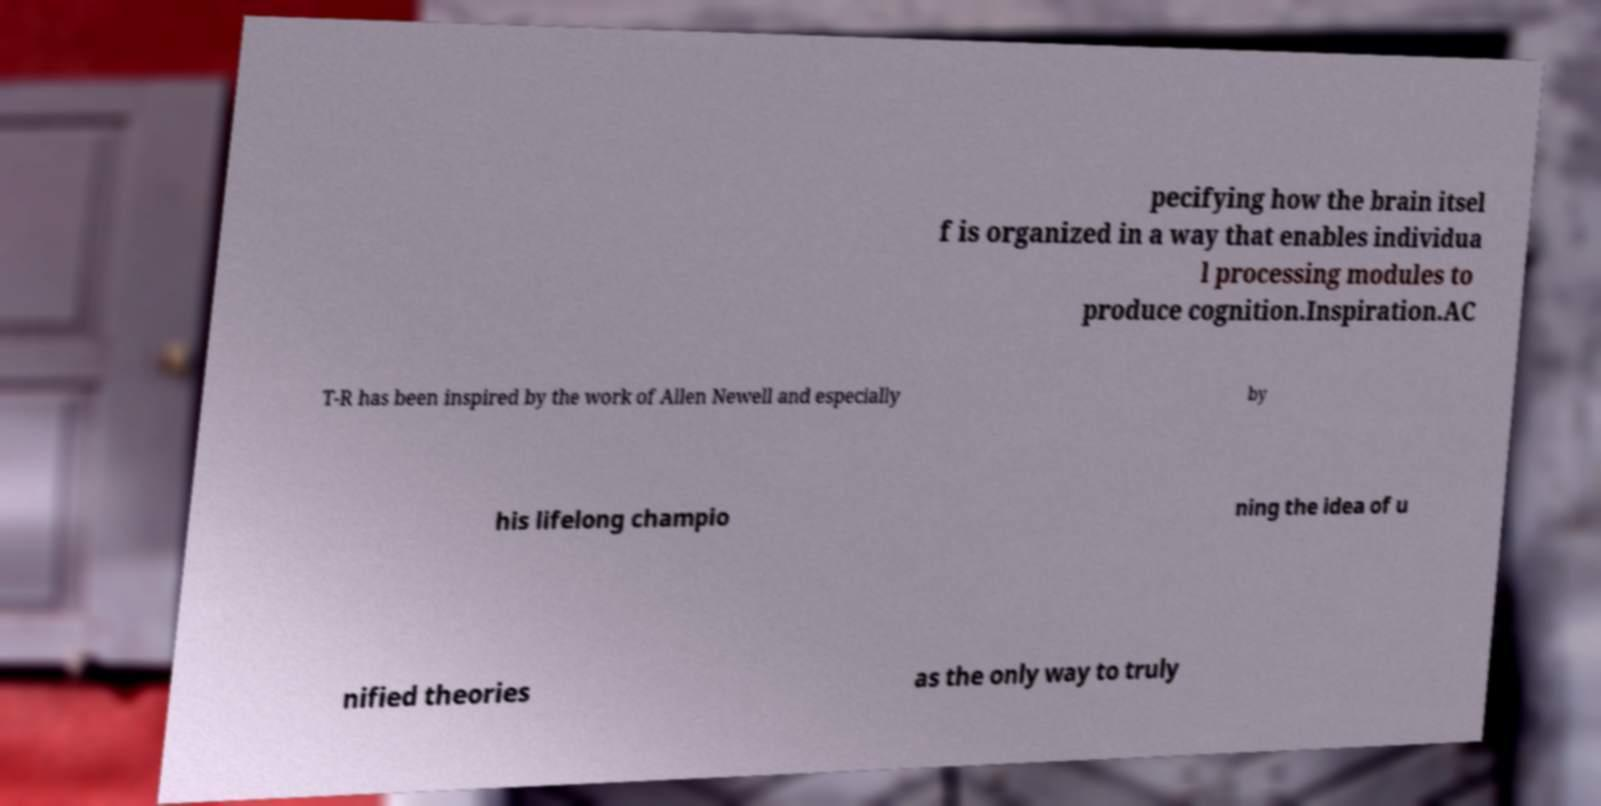Can you read and provide the text displayed in the image?This photo seems to have some interesting text. Can you extract and type it out for me? pecifying how the brain itsel f is organized in a way that enables individua l processing modules to produce cognition.Inspiration.AC T-R has been inspired by the work of Allen Newell and especially by his lifelong champio ning the idea of u nified theories as the only way to truly 